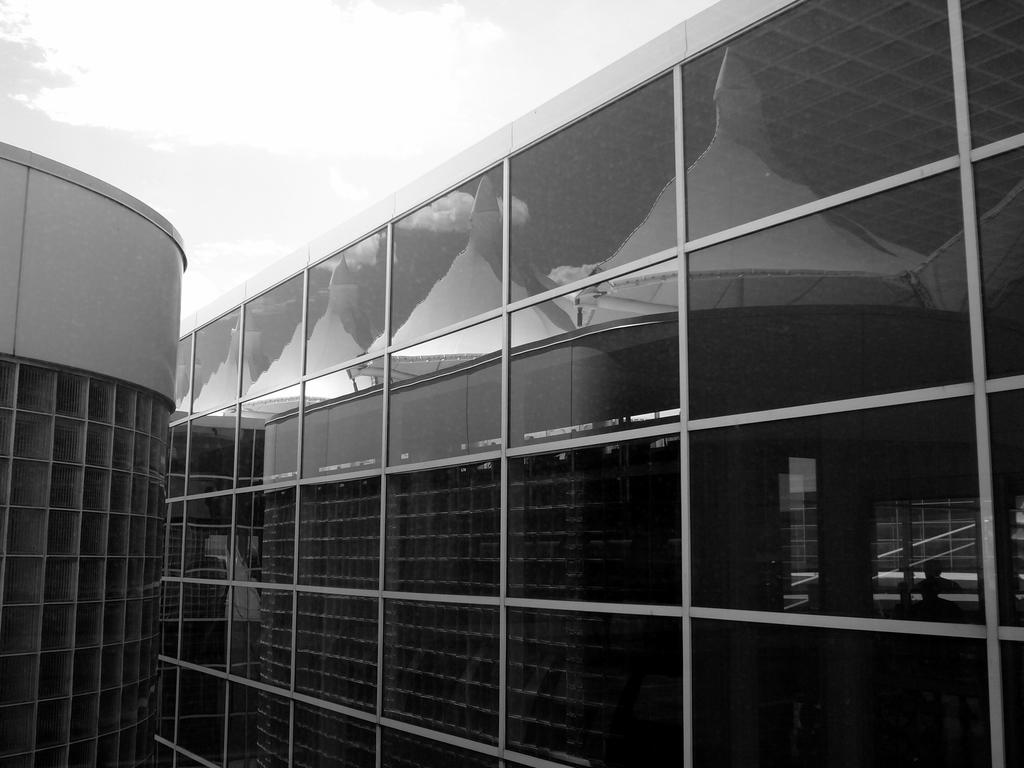What type of structures are present in the image? There are buildings in the image. What feature can be observed on the buildings? The buildings have glass windows. What is the condition of the sky in the image? The sky is cloudy in the image. Can you tell me how many zebras are grazing in front of the buildings in the image? There are no zebras present in the image; it features buildings with glass windows and a cloudy sky. What type of fuel is being used by the buildings in the image? The image does not provide information about the type of fuel being used by the buildings. 